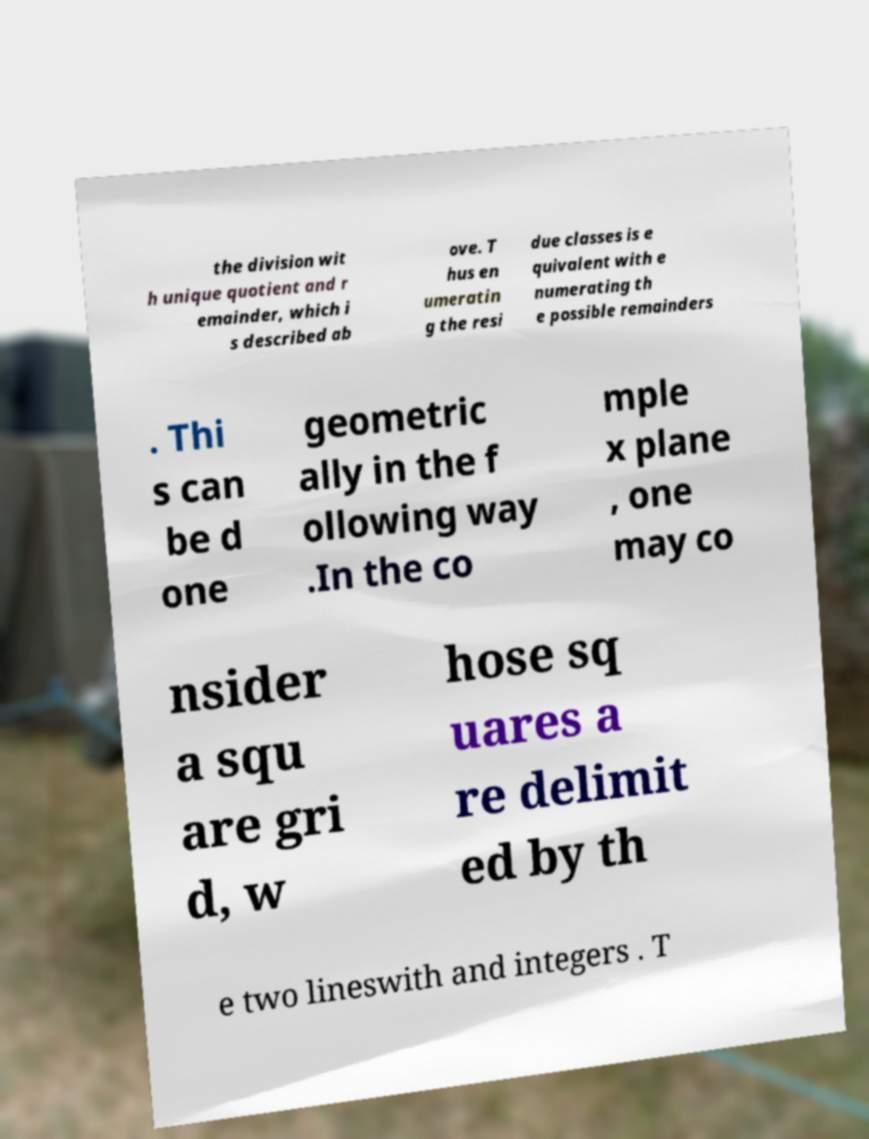Could you assist in decoding the text presented in this image and type it out clearly? the division wit h unique quotient and r emainder, which i s described ab ove. T hus en umeratin g the resi due classes is e quivalent with e numerating th e possible remainders . Thi s can be d one geometric ally in the f ollowing way .In the co mple x plane , one may co nsider a squ are gri d, w hose sq uares a re delimit ed by th e two lineswith and integers . T 